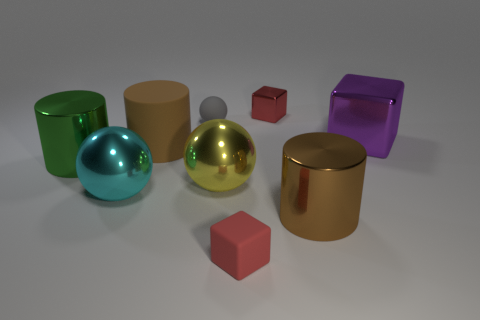Is there a shiny thing?
Your answer should be very brief. Yes. There is a red thing behind the matte cylinder; does it have the same shape as the small thing left of the matte block?
Keep it short and to the point. No. What number of small things are either cyan spheres or red things?
Give a very brief answer. 2. There is a small red thing that is the same material as the small gray sphere; what is its shape?
Provide a succinct answer. Cube. Is the big green metal object the same shape as the tiny red shiny thing?
Offer a very short reply. No. The tiny sphere is what color?
Provide a short and direct response. Gray. How many things are metal blocks or big cyan metal things?
Offer a very short reply. 3. Are there any other things that have the same material as the yellow object?
Give a very brief answer. Yes. Is the number of shiny cubes that are behind the small metal thing less than the number of rubber cubes?
Your response must be concise. Yes. Are there more objects that are in front of the red shiny thing than cyan metallic things that are on the left side of the large green thing?
Keep it short and to the point. Yes. 